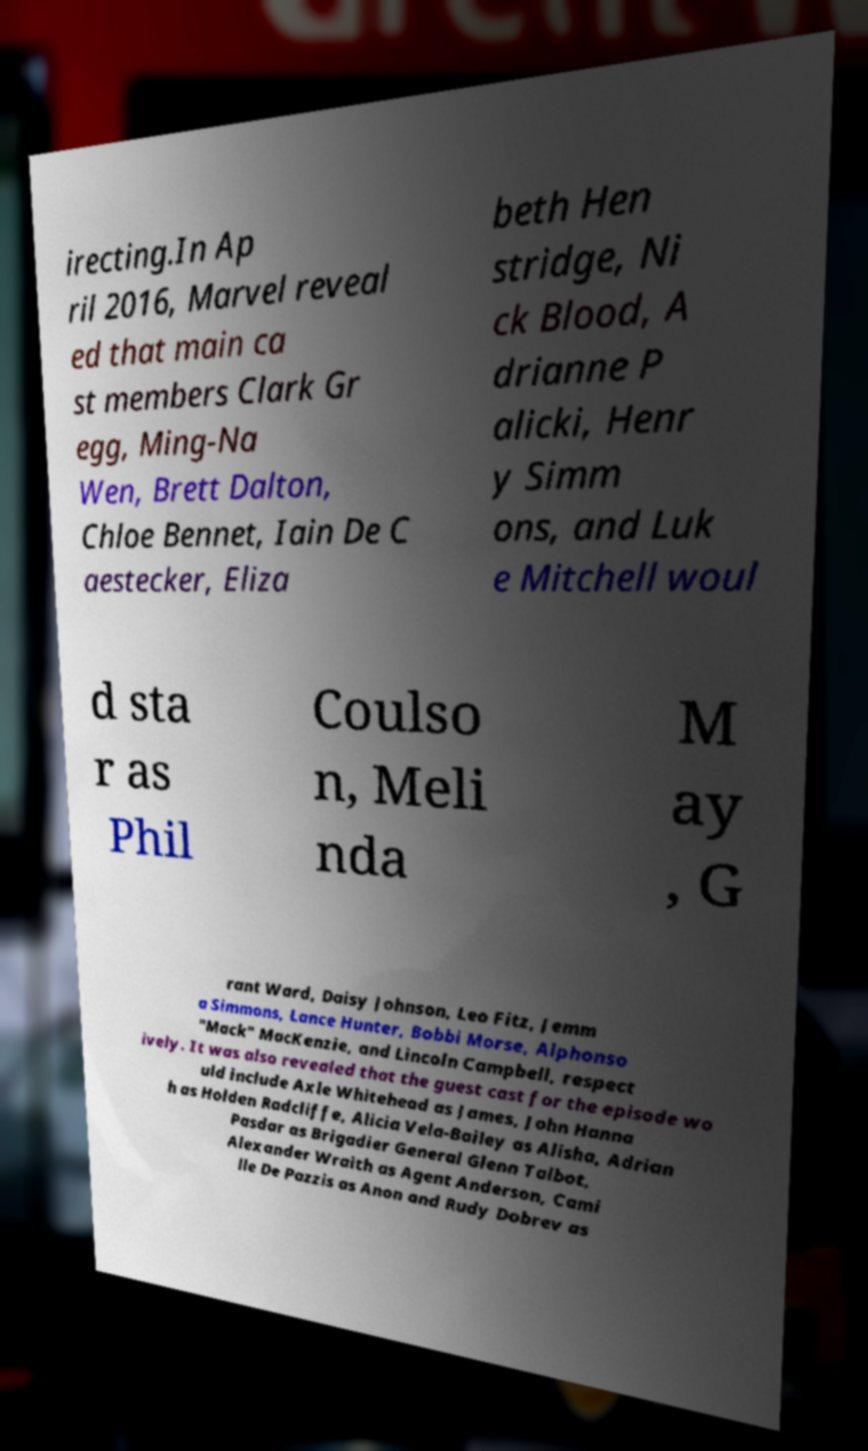Can you accurately transcribe the text from the provided image for me? irecting.In Ap ril 2016, Marvel reveal ed that main ca st members Clark Gr egg, Ming-Na Wen, Brett Dalton, Chloe Bennet, Iain De C aestecker, Eliza beth Hen stridge, Ni ck Blood, A drianne P alicki, Henr y Simm ons, and Luk e Mitchell woul d sta r as Phil Coulso n, Meli nda M ay , G rant Ward, Daisy Johnson, Leo Fitz, Jemm a Simmons, Lance Hunter, Bobbi Morse, Alphonso "Mack" MacKenzie, and Lincoln Campbell, respect ively. It was also revealed that the guest cast for the episode wo uld include Axle Whitehead as James, John Hanna h as Holden Radcliffe, Alicia Vela-Bailey as Alisha, Adrian Pasdar as Brigadier General Glenn Talbot, Alexander Wraith as Agent Anderson, Cami lle De Pazzis as Anon and Rudy Dobrev as 